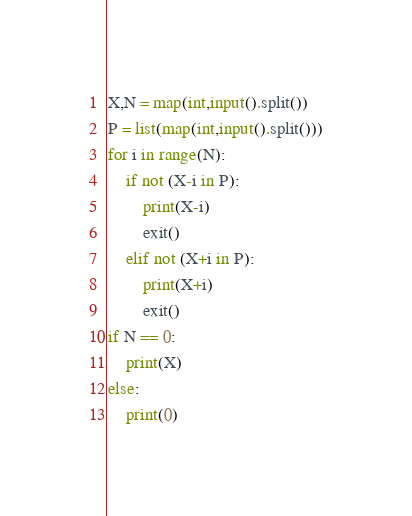<code> <loc_0><loc_0><loc_500><loc_500><_Python_>X,N = map(int,input().split())
P = list(map(int,input().split()))
for i in range(N):
    if not (X-i in P):
        print(X-i)
        exit()
    elif not (X+i in P):
        print(X+i)
        exit()
if N == 0:
    print(X)
else:
    print(0)</code> 